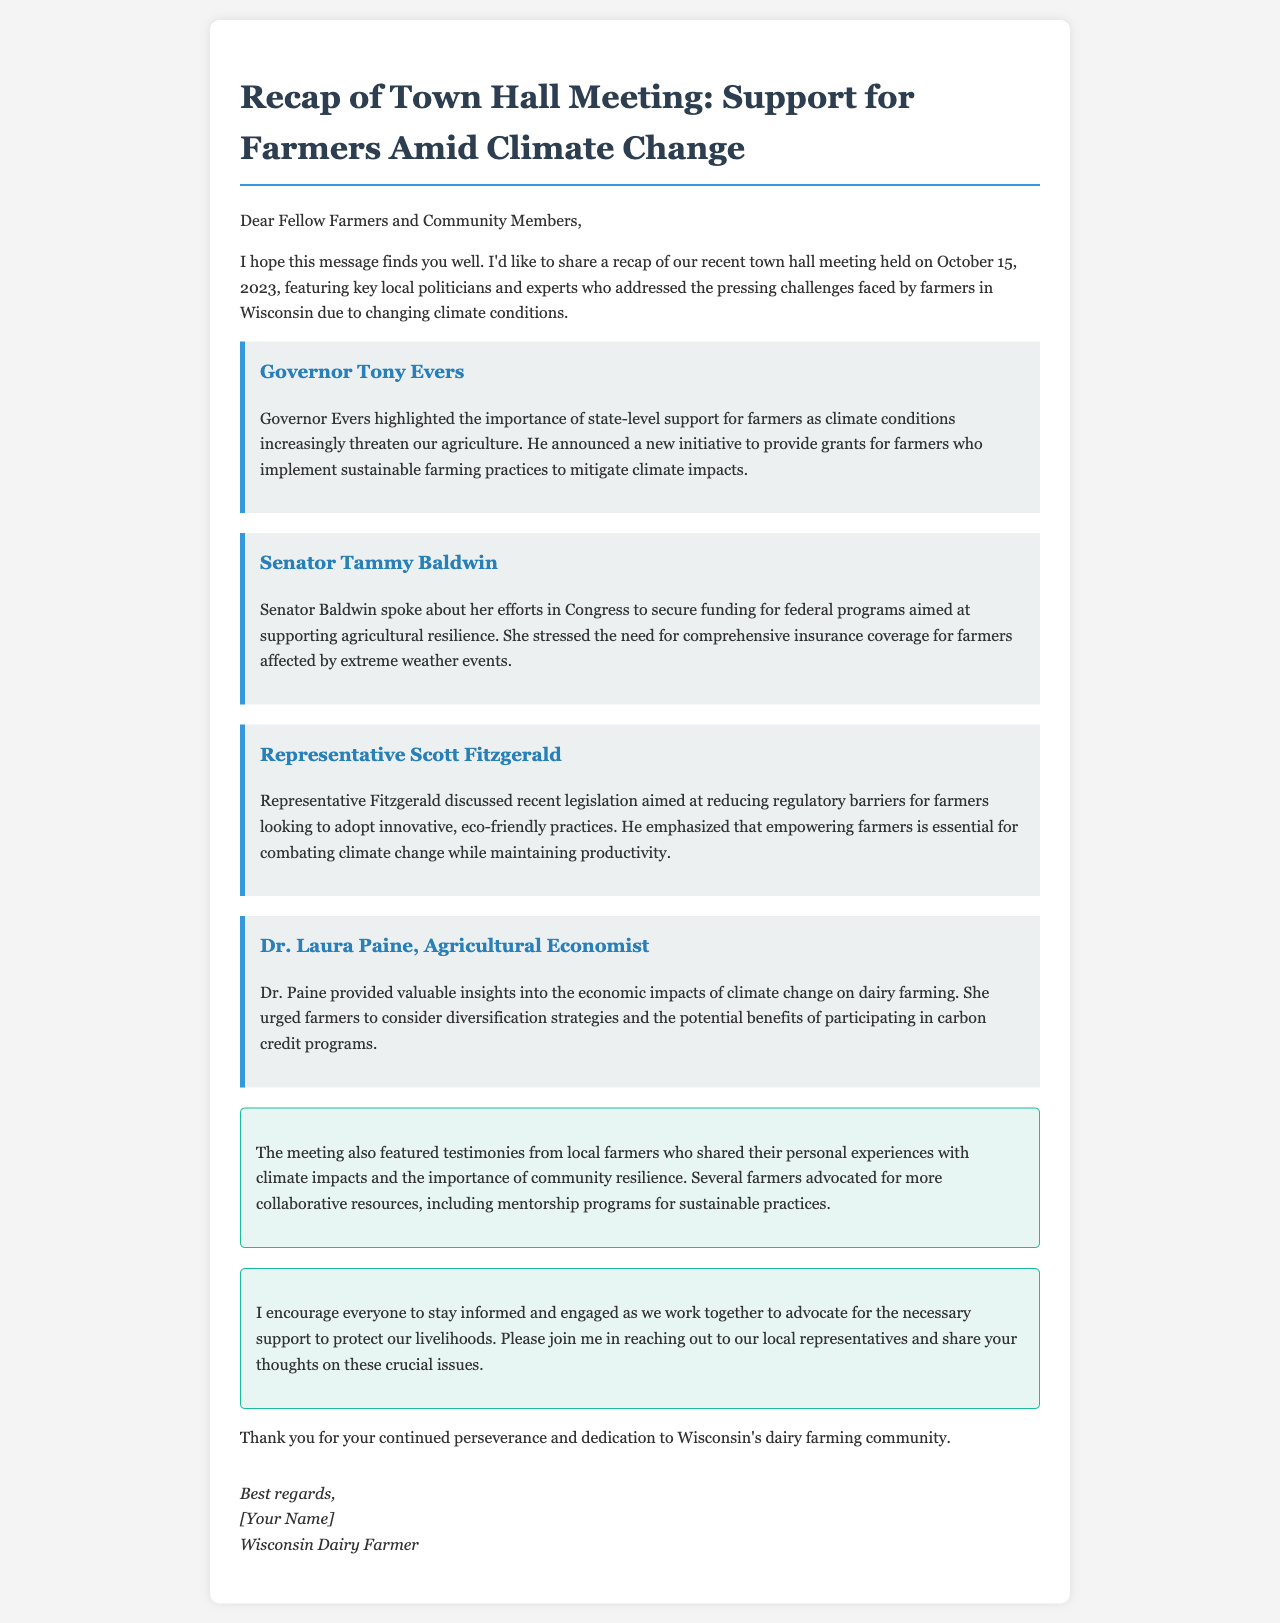What date was the town hall meeting held? The date of the town hall meeting is specifically mentioned in the email, which is October 15, 2023.
Answer: October 15, 2023 Who highlighted the importance of state-level support for farmers? The speaker who emphasized state-level support is identified as Governor Tony Evers in the document.
Answer: Governor Tony Evers What initiative was announced by Governor Evers? The document states that Governor Evers announced a new initiative to provide grants for farmers who implement sustainable farming practices.
Answer: Grants for sustainable farming What did Senator Baldwin emphasize in her speech? Senator Baldwin discussed her efforts to secure funding for programs aimed at supporting agricultural resilience and stressed the need for comprehensive insurance coverage.
Answer: Comprehensive insurance coverage What did Dr. Paine urge farmers to consider? Dr. Laura Paine urged farmers to consider diversification strategies and the potential benefits of participating in carbon credit programs.
Answer: Diversification strategies What was a theme among local farmers' testimonies? The testimonies from local farmers shared their experiences with climate impacts and emphasized the importance of community resilience.
Answer: Community resilience What is the call to action mentioned in the document? The call to action encourages farmers to stay informed and engage with local representatives regarding support for farmers, which is articulated in the email.
Answer: Engage with local representatives What position does Scott Fitzgerald hold? The document identifies Scott Fitzgerald as a Representative, making it clear what his political position is.
Answer: Representative 